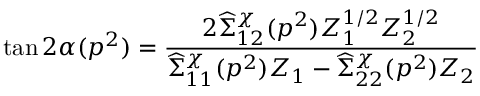<formula> <loc_0><loc_0><loc_500><loc_500>\tan 2 \alpha ( p ^ { 2 } ) = { \frac { 2 \widehat { \Sigma } _ { 1 2 } ^ { \chi } ( p ^ { 2 } ) Z _ { 1 } ^ { 1 / 2 } Z _ { 2 } ^ { 1 / 2 } } { \widehat { \Sigma } _ { 1 1 } ^ { \chi } ( p ^ { 2 } ) Z _ { 1 } - \widehat { \Sigma } _ { 2 2 } ^ { \chi } ( p ^ { 2 } ) Z _ { 2 } } }</formula> 